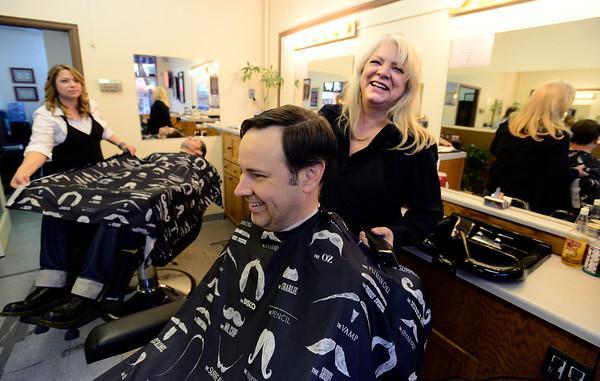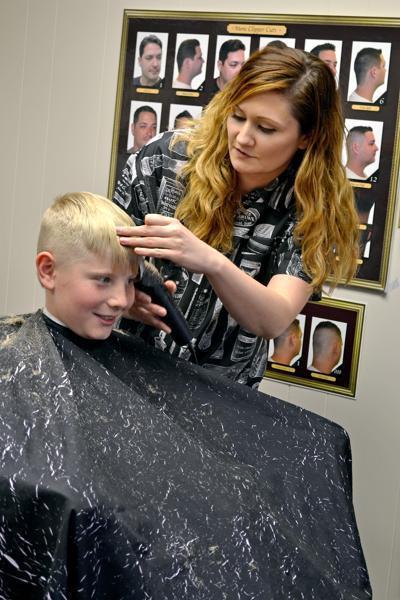The first image is the image on the left, the second image is the image on the right. For the images displayed, is the sentence "An image shows a woman with light blonde hair behind an adult male customer." factually correct? Answer yes or no. Yes. The first image is the image on the left, the second image is the image on the right. Given the left and right images, does the statement "The person in the image on the right is covered with a black smock" hold true? Answer yes or no. Yes. 